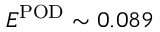<formula> <loc_0><loc_0><loc_500><loc_500>E ^ { P O D } \sim 0 . 0 8 9</formula> 